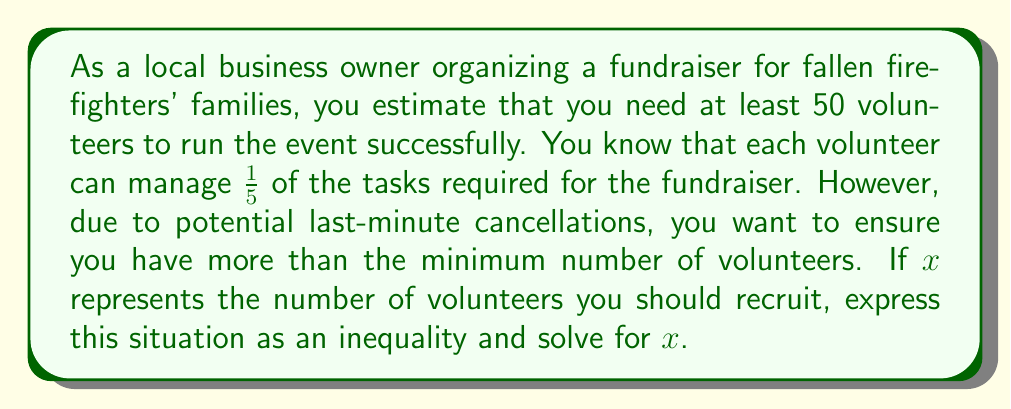Teach me how to tackle this problem. Let's approach this step-by-step:

1) First, we need to set up our inequality. We know that:
   - Each volunteer can manage $\frac{1}{5}$ of the tasks
   - We need at least 50 volunteers worth of work
   - We want more than the minimum number of volunteers

2) Let $x$ be the number of volunteers we recruit. The total amount of work they can do is $\frac{x}{5}$.

3) This should be greater than 50:

   $$\frac{x}{5} > 50$$

4) To solve this inequality, we multiply both sides by 5:

   $$x > 50 \cdot 5$$

5) Simplify:

   $$x > 250$$

6) Since $x$ represents the number of volunteers, and we can't have a fractional number of volunteers, we need to round up to the nearest whole number.

Therefore, the minimum number of volunteers needed is 251.
Answer: $x > 250$, so the minimum number of volunteers to recruit is 251. 